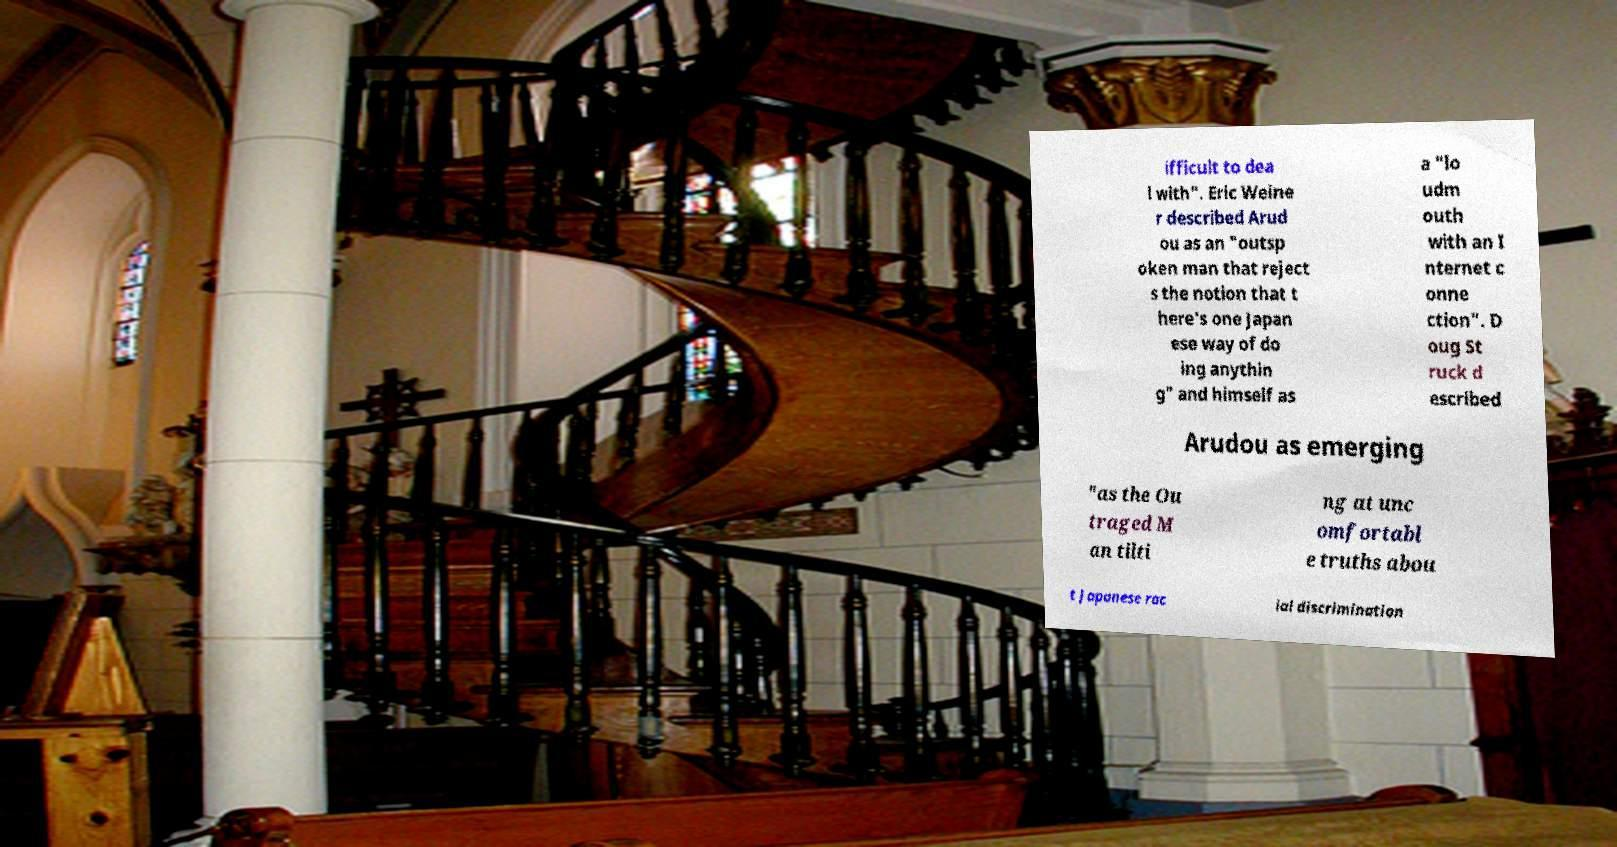Could you extract and type out the text from this image? ifficult to dea l with". Eric Weine r described Arud ou as an "outsp oken man that reject s the notion that t here's one Japan ese way of do ing anythin g" and himself as a "lo udm outh with an I nternet c onne ction". D oug St ruck d escribed Arudou as emerging "as the Ou traged M an tilti ng at unc omfortabl e truths abou t Japanese rac ial discrimination 